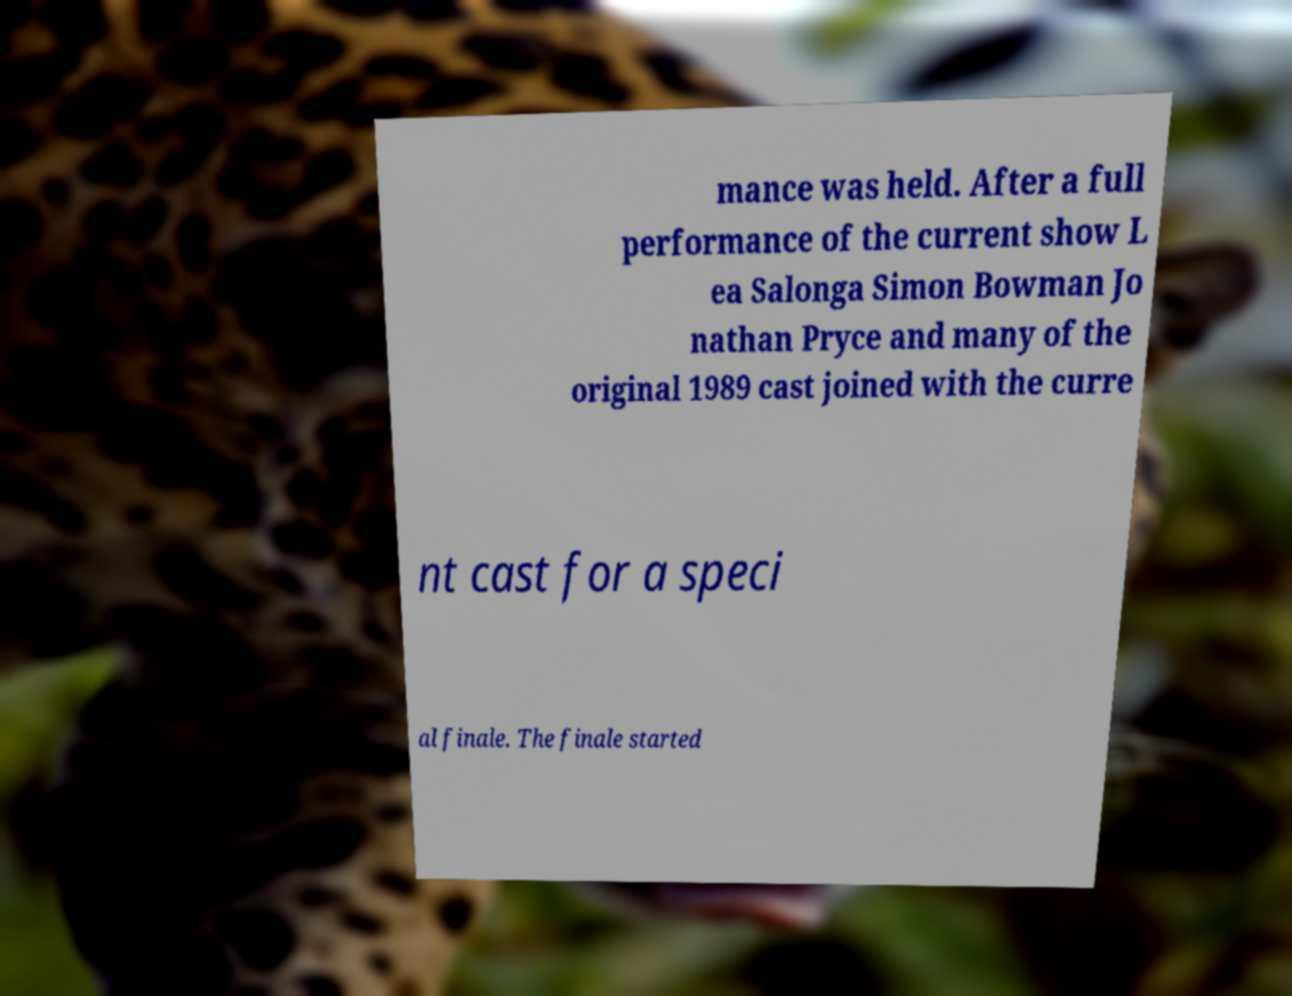Could you extract and type out the text from this image? mance was held. After a full performance of the current show L ea Salonga Simon Bowman Jo nathan Pryce and many of the original 1989 cast joined with the curre nt cast for a speci al finale. The finale started 